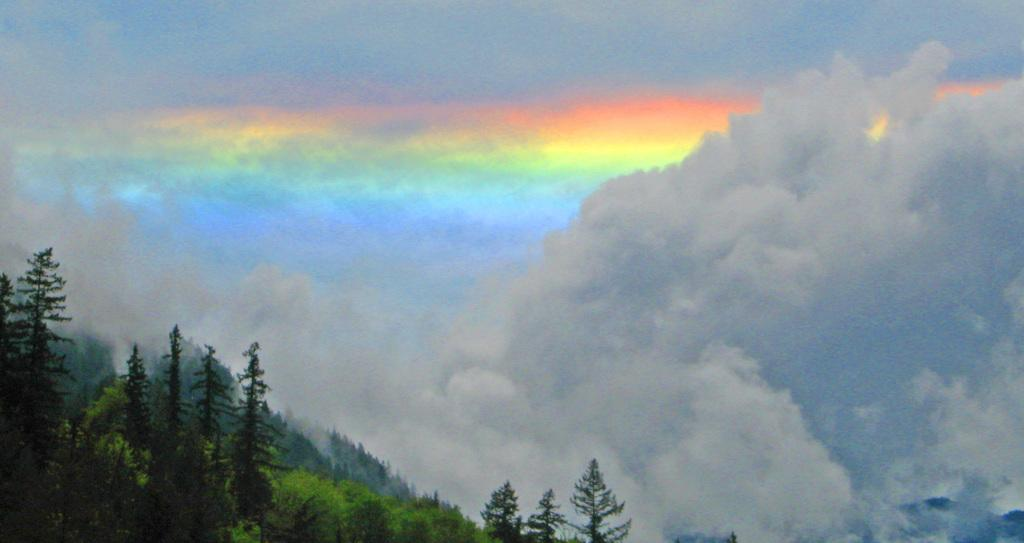What natural phenomenon can be seen in the image? There is a rainbow in the image. What type of vegetation is present in the image? There are plants in the image. What part of the natural environment is visible in the image? The sky is visible in the image. What type of monkey can be seen climbing the rainbow in the image? There is no monkey present in the image; it only features a rainbow and plants. 